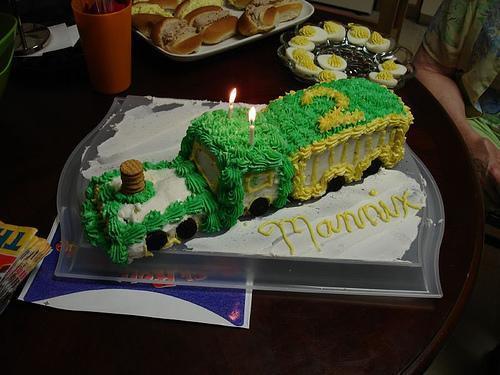How many desserts are pictured?
Give a very brief answer. 1. How many years old is the recipient of this birthday cake?
Give a very brief answer. 2. How many candles are there?
Give a very brief answer. 2. How many candles on the cake?
Give a very brief answer. 2. How many cakes are in the picture?
Give a very brief answer. 1. 